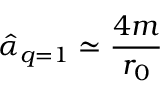Convert formula to latex. <formula><loc_0><loc_0><loc_500><loc_500>\hat { \alpha } _ { q = 1 } \simeq \frac { 4 m } { r _ { 0 } }</formula> 